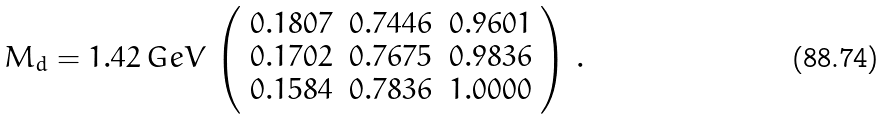<formula> <loc_0><loc_0><loc_500><loc_500>M _ { d } = 1 . 4 2 \, G e V \, \left ( \begin{array} { c c c } 0 . 1 8 0 7 & 0 . 7 4 4 6 & 0 . 9 6 0 1 \\ 0 . 1 7 0 2 & 0 . 7 6 7 5 & 0 . 9 8 3 6 \\ 0 . 1 5 8 4 & 0 . 7 8 3 6 & 1 . 0 0 0 0 \end{array} \right ) \, .</formula> 